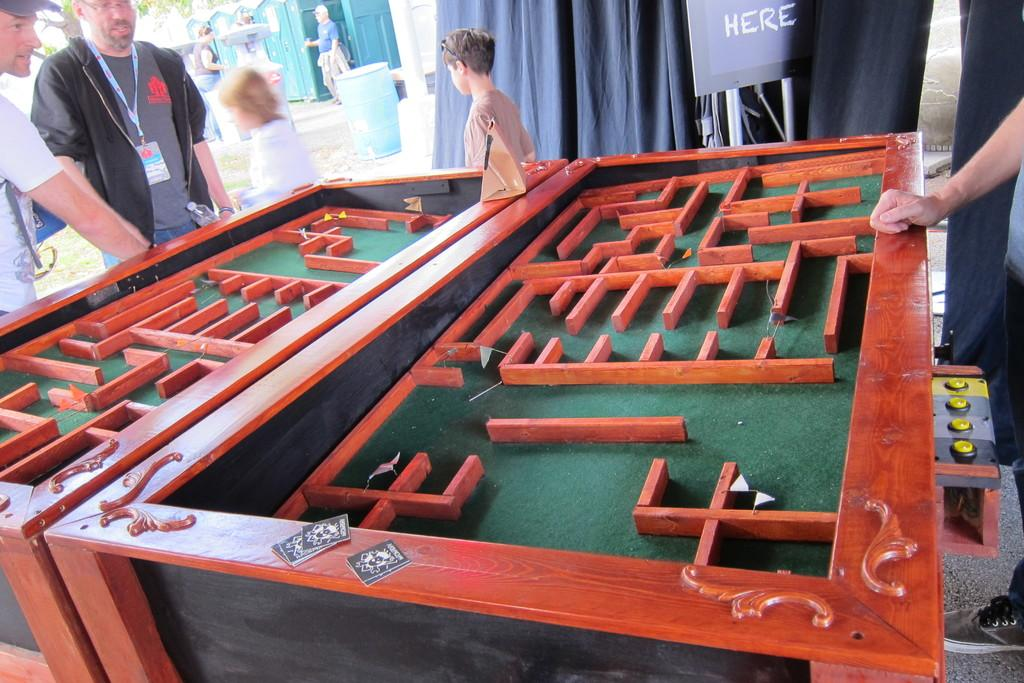What are the people in the image standing in front of? The people in the image are standing in front of a maze table. Can you describe the background of the image? In the background, there is a person standing at a booth, a curtain, a banner, a tree, and a drum. How many people can be seen in the image? The number of people in the image cannot be determined from the provided facts. What type of crate is being used to store the lock in the image? There is no crate or lock present in the image. 